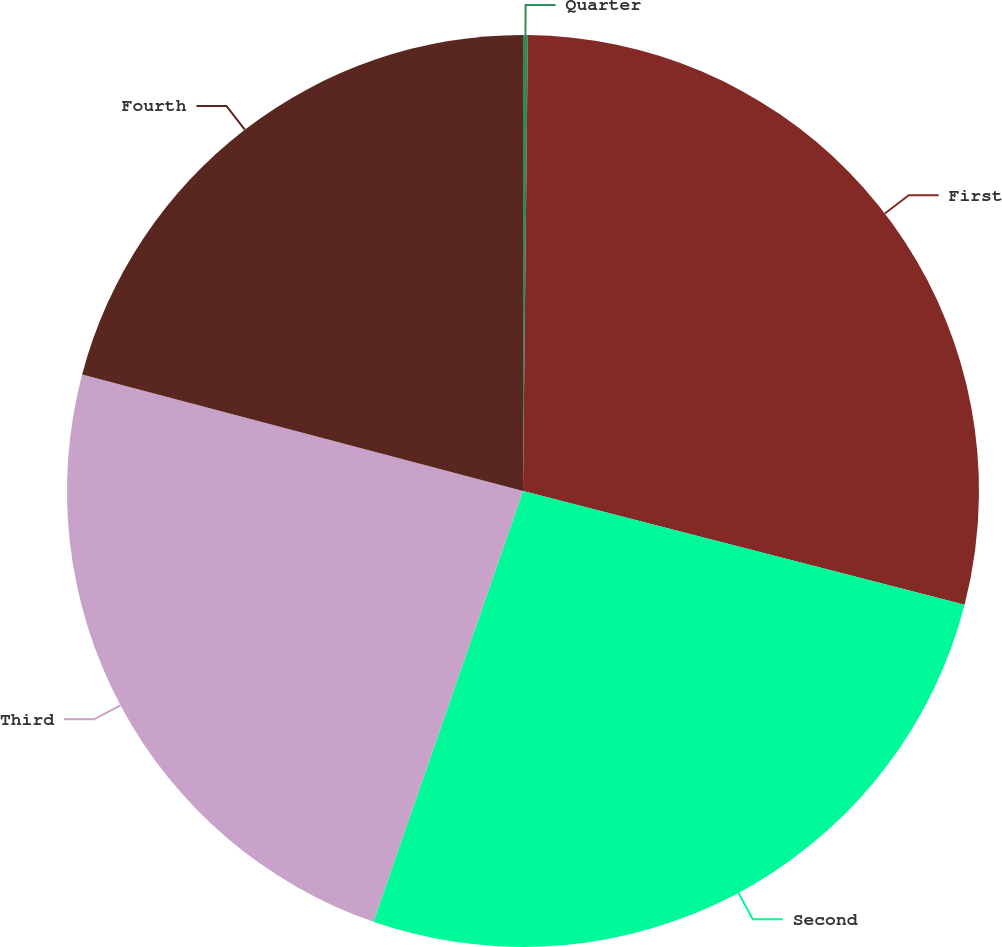Convert chart. <chart><loc_0><loc_0><loc_500><loc_500><pie_chart><fcel>Quarter<fcel>First<fcel>Second<fcel>Third<fcel>Fourth<nl><fcel>0.17%<fcel>28.84%<fcel>26.31%<fcel>23.79%<fcel>20.89%<nl></chart> 